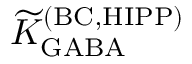<formula> <loc_0><loc_0><loc_500><loc_500>{ \widetilde { K } } _ { G A B A } ^ { ( B C , H I P P ) }</formula> 